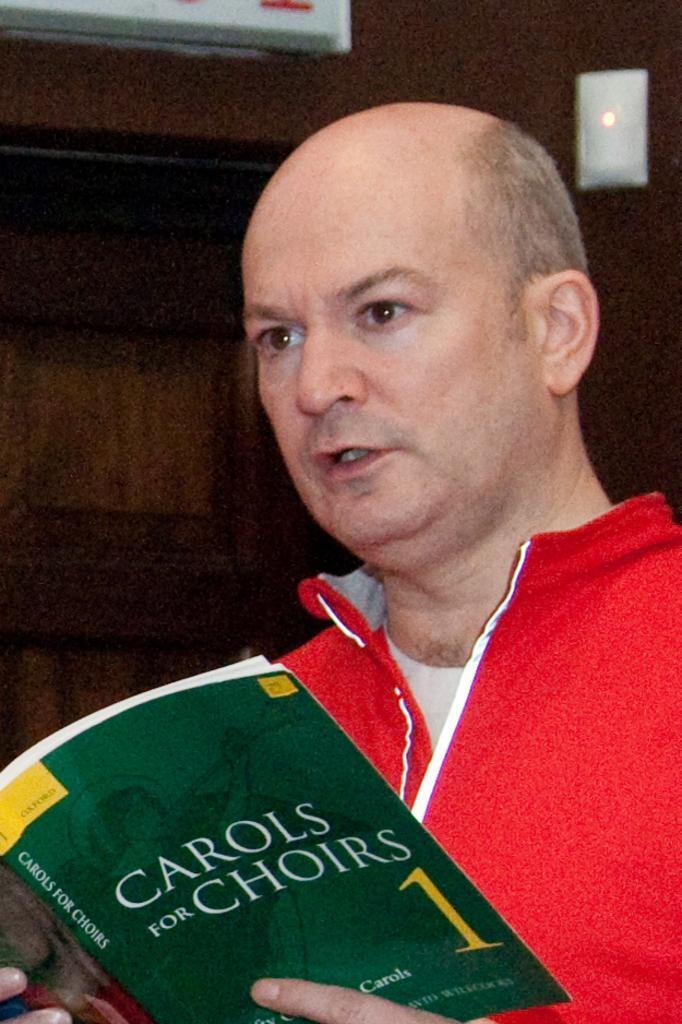Describe this image in one or two sentences. In this image I can see a person wearing red and white colored jacket is holding a book in his hand. In the background I can see the brown colored surface and a white colored object. 